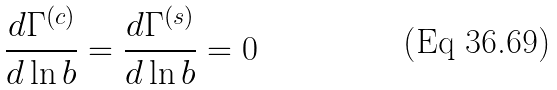<formula> <loc_0><loc_0><loc_500><loc_500>\frac { d \Gamma ^ { ( c ) } } { d \ln b } = \frac { d \Gamma ^ { ( s ) } } { d \ln b } = 0</formula> 